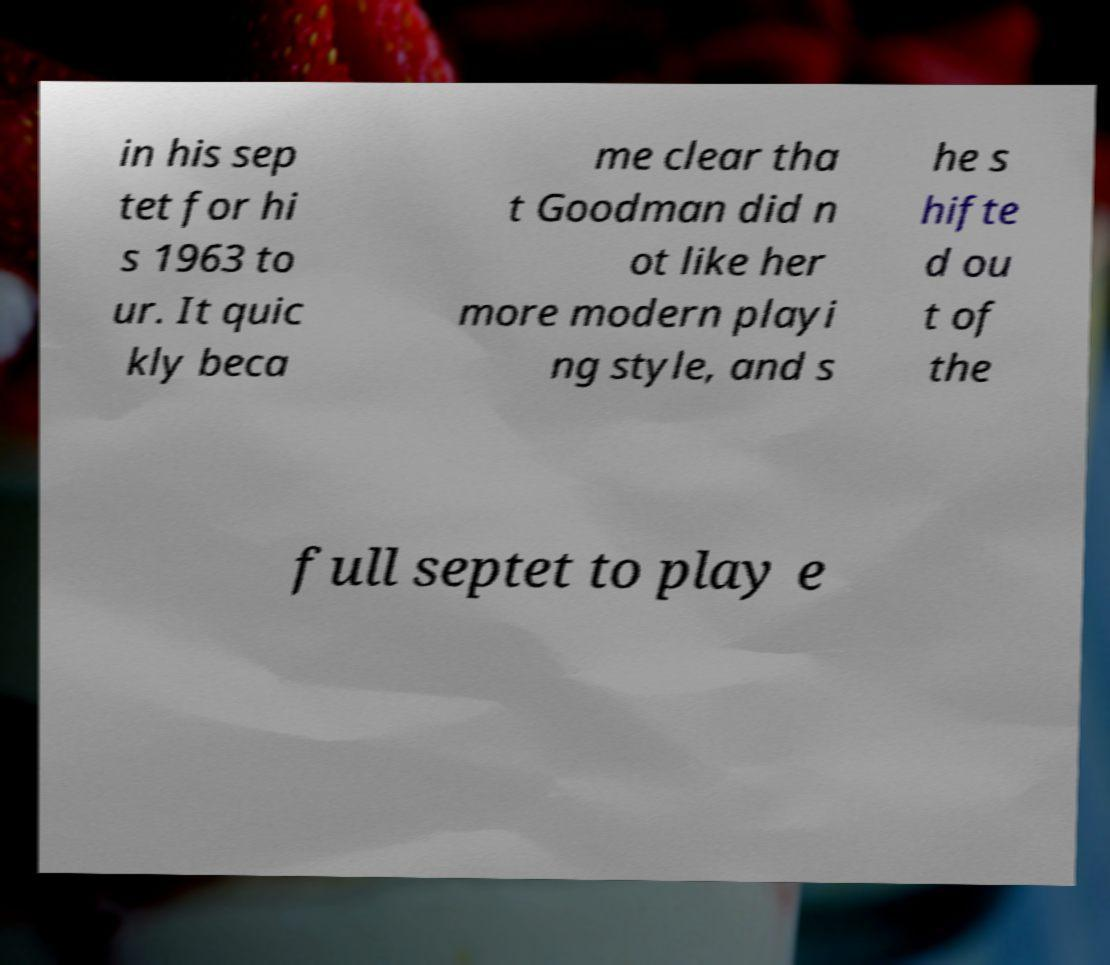I need the written content from this picture converted into text. Can you do that? in his sep tet for hi s 1963 to ur. It quic kly beca me clear tha t Goodman did n ot like her more modern playi ng style, and s he s hifte d ou t of the full septet to play e 